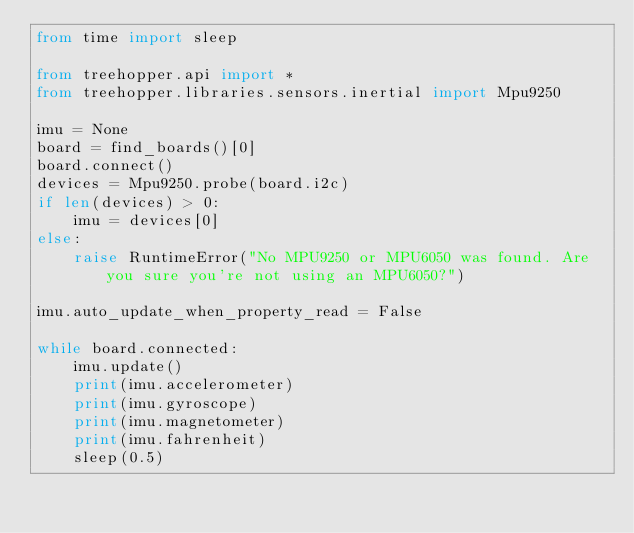Convert code to text. <code><loc_0><loc_0><loc_500><loc_500><_Python_>from time import sleep

from treehopper.api import *
from treehopper.libraries.sensors.inertial import Mpu9250

imu = None
board = find_boards()[0]
board.connect()
devices = Mpu9250.probe(board.i2c)
if len(devices) > 0:
    imu = devices[0]
else:
    raise RuntimeError("No MPU9250 or MPU6050 was found. Are you sure you're not using an MPU6050?")

imu.auto_update_when_property_read = False

while board.connected:
    imu.update()
    print(imu.accelerometer)
    print(imu.gyroscope)
    print(imu.magnetometer)
    print(imu.fahrenheit)
    sleep(0.5)
</code> 